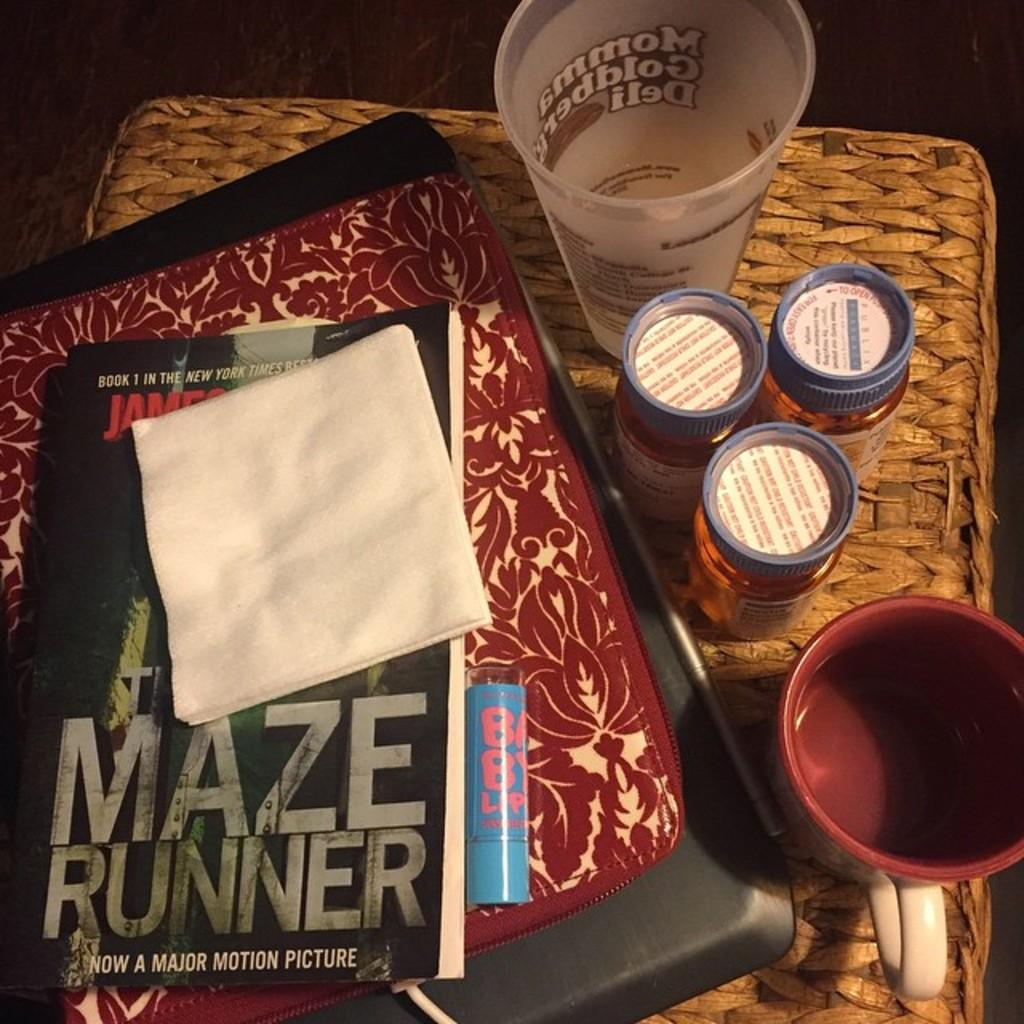<image>
Summarize the visual content of the image. A copy of the Maze Runner is sitting on top of a wicker ottoman. 